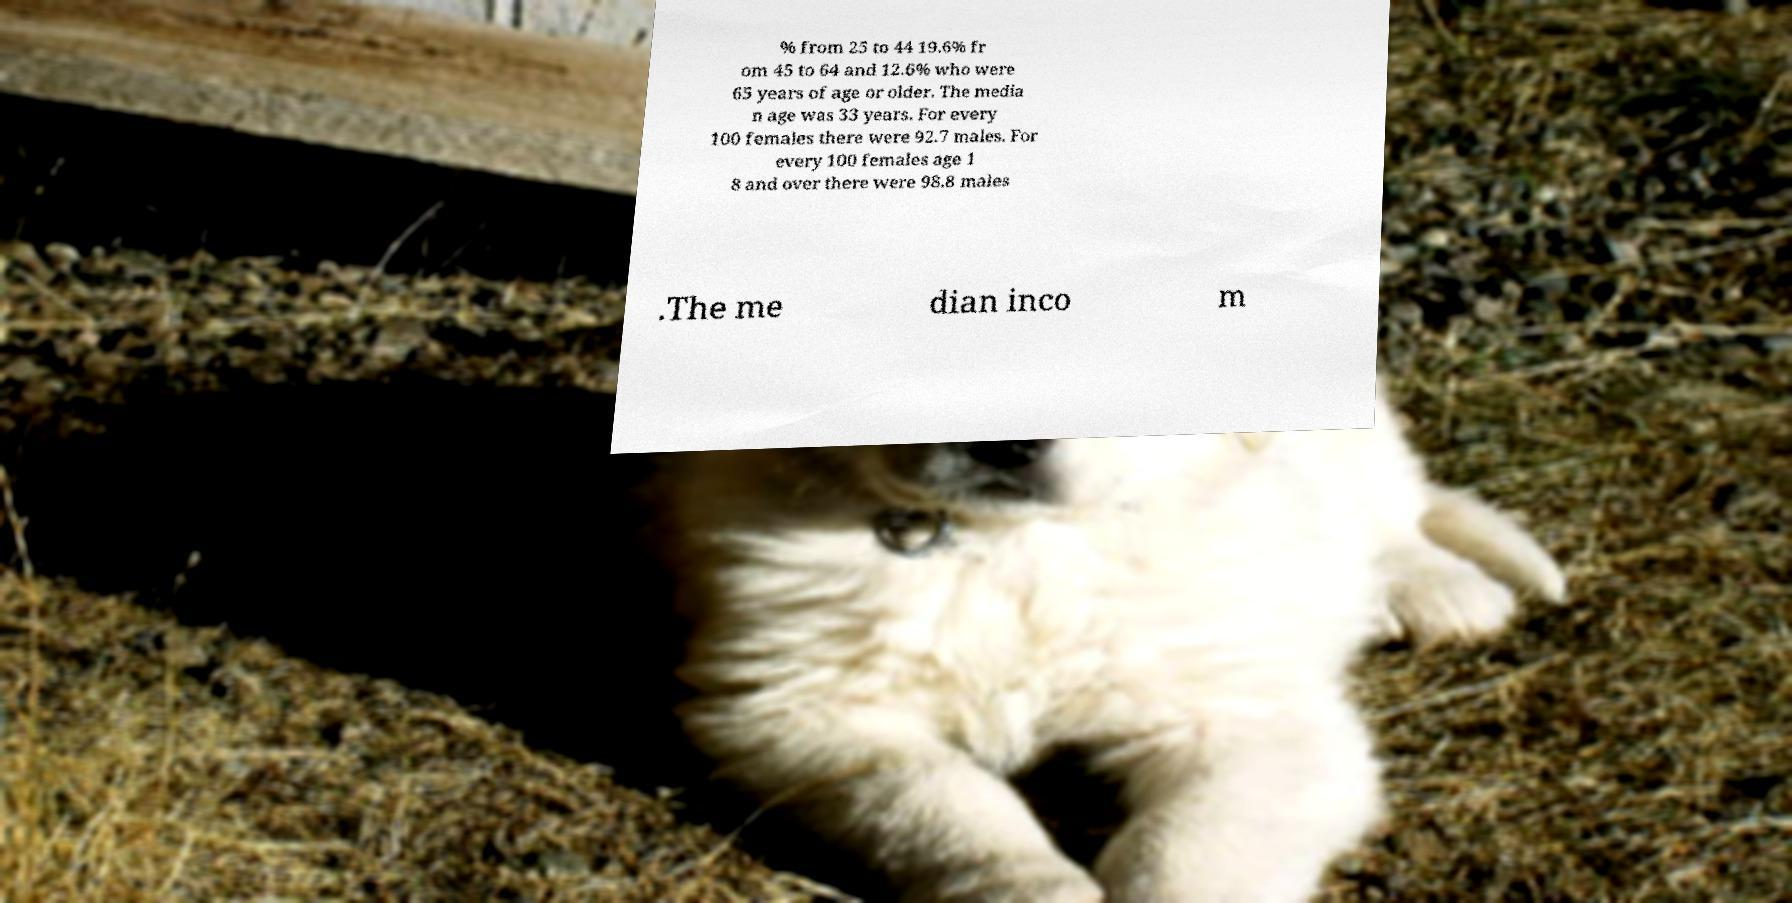I need the written content from this picture converted into text. Can you do that? % from 25 to 44 19.6% fr om 45 to 64 and 12.6% who were 65 years of age or older. The media n age was 33 years. For every 100 females there were 92.7 males. For every 100 females age 1 8 and over there were 98.8 males .The me dian inco m 